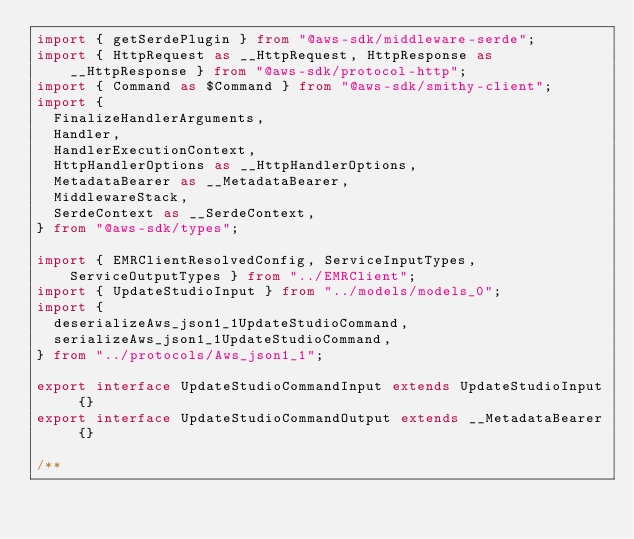Convert code to text. <code><loc_0><loc_0><loc_500><loc_500><_TypeScript_>import { getSerdePlugin } from "@aws-sdk/middleware-serde";
import { HttpRequest as __HttpRequest, HttpResponse as __HttpResponse } from "@aws-sdk/protocol-http";
import { Command as $Command } from "@aws-sdk/smithy-client";
import {
  FinalizeHandlerArguments,
  Handler,
  HandlerExecutionContext,
  HttpHandlerOptions as __HttpHandlerOptions,
  MetadataBearer as __MetadataBearer,
  MiddlewareStack,
  SerdeContext as __SerdeContext,
} from "@aws-sdk/types";

import { EMRClientResolvedConfig, ServiceInputTypes, ServiceOutputTypes } from "../EMRClient";
import { UpdateStudioInput } from "../models/models_0";
import {
  deserializeAws_json1_1UpdateStudioCommand,
  serializeAws_json1_1UpdateStudioCommand,
} from "../protocols/Aws_json1_1";

export interface UpdateStudioCommandInput extends UpdateStudioInput {}
export interface UpdateStudioCommandOutput extends __MetadataBearer {}

/**</code> 